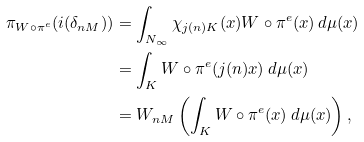Convert formula to latex. <formula><loc_0><loc_0><loc_500><loc_500>\pi _ { W \circ \pi ^ { e } } ( i ( \delta _ { n M } ) ) & = \int _ { N _ { \infty } } \chi _ { j ( n ) K } ( x ) W \circ \pi ^ { e } ( x ) \, d \mu ( x ) \\ & = \int _ { K } W \circ \pi ^ { e } ( j ( n ) x ) \, d \mu ( x ) \\ & = W _ { n M } \left ( \int _ { K } W \circ \pi ^ { e } ( x ) \, d \mu ( x ) \right ) ,</formula> 